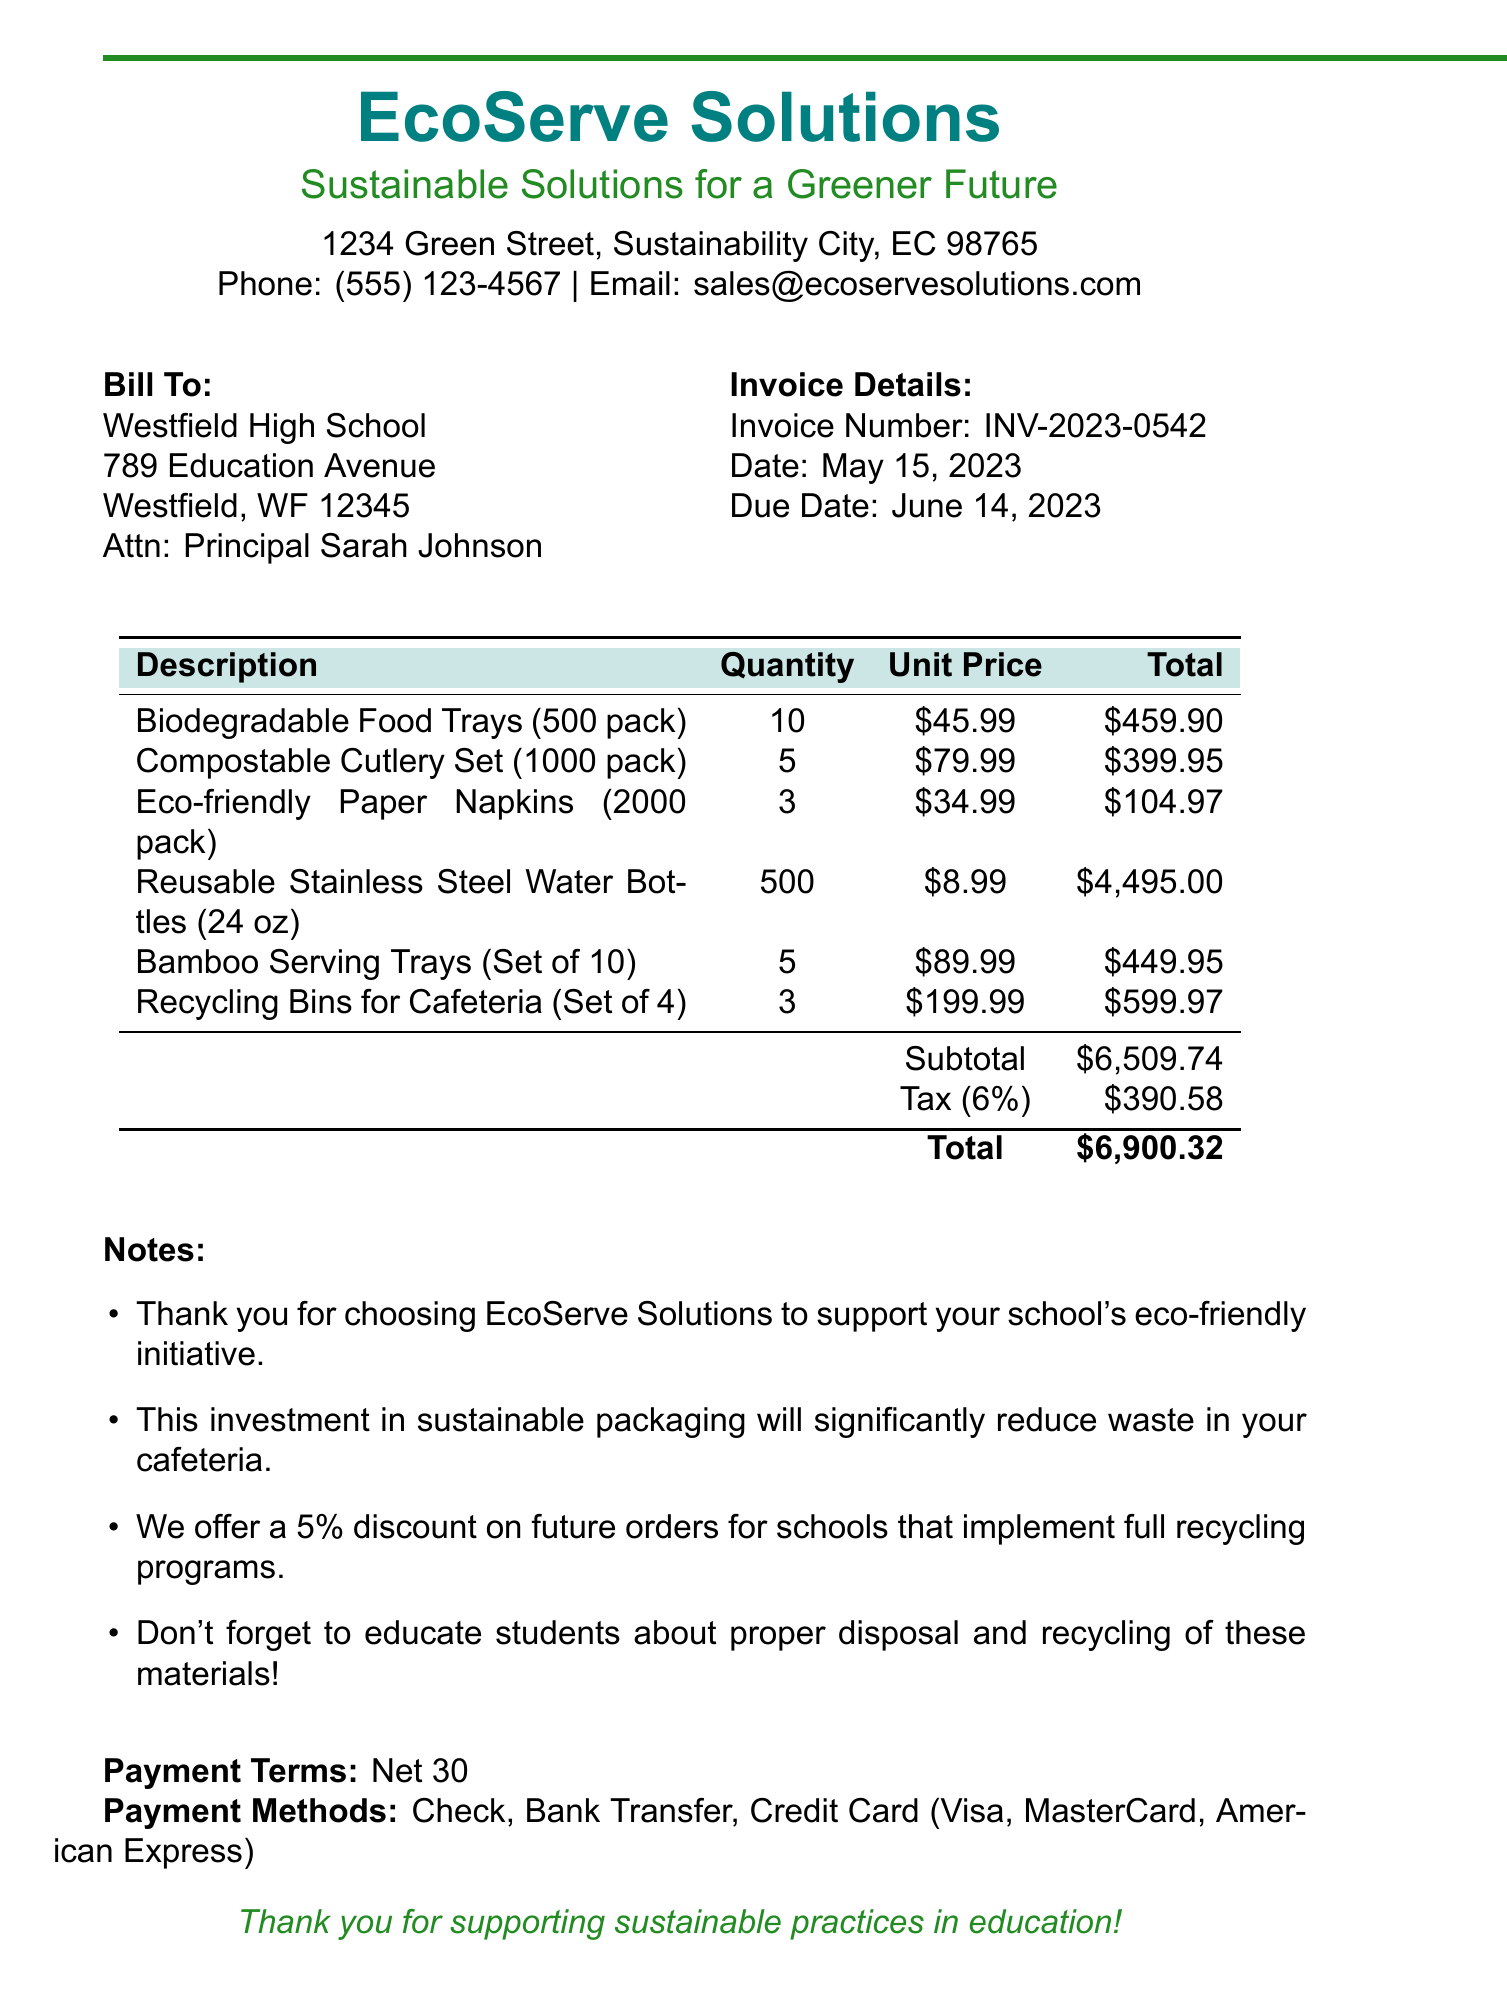What is the invoice number? The invoice number is clearly stated in the document, identifying this specific transaction.
Answer: INV-2023-0542 What is the total amount due? The total amount due is listed at the bottom of the invoice, summarizing the costs after tax.
Answer: $6900.32 Who is the contact person for this invoice? The contact person for this invoice is mentioned to ensure proper communication regarding the order.
Answer: Principal Sarah Johnson What is the payment term specified in this invoice? The payment terms provide important information regarding when payment is due after the invoice date.
Answer: Net 30 How many packs of biodegradable food trays were ordered? The quantity of biodegradable food trays shows how many of this item were included in the order.
Answer: 10 What discount is offered for future orders? The discount policy is mentioned to encourage schools to consider ongoing purchasing.
Answer: 5% discount What is the tax rate applied to the invoice? The tax rate is important for calculating the total cost that includes tax, which is specified in the document.
Answer: 6% What type of payment methods are accepted? The accepted payment methods are listed to inform the buyer of various options for settlement.
Answer: Check, Bank Transfer, Credit Card (Visa, MasterCard, American Express) How many recycling bins for the cafeteria were ordered? The quantity of recycling bins ordered reflects the school's commitment to sustainability practices.
Answer: 3 